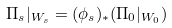Convert formula to latex. <formula><loc_0><loc_0><loc_500><loc_500>\Pi _ { s } | _ { W _ { s } } = ( \phi _ { s } ) _ { * } ( \Pi _ { 0 } | _ { W _ { 0 } } )</formula> 